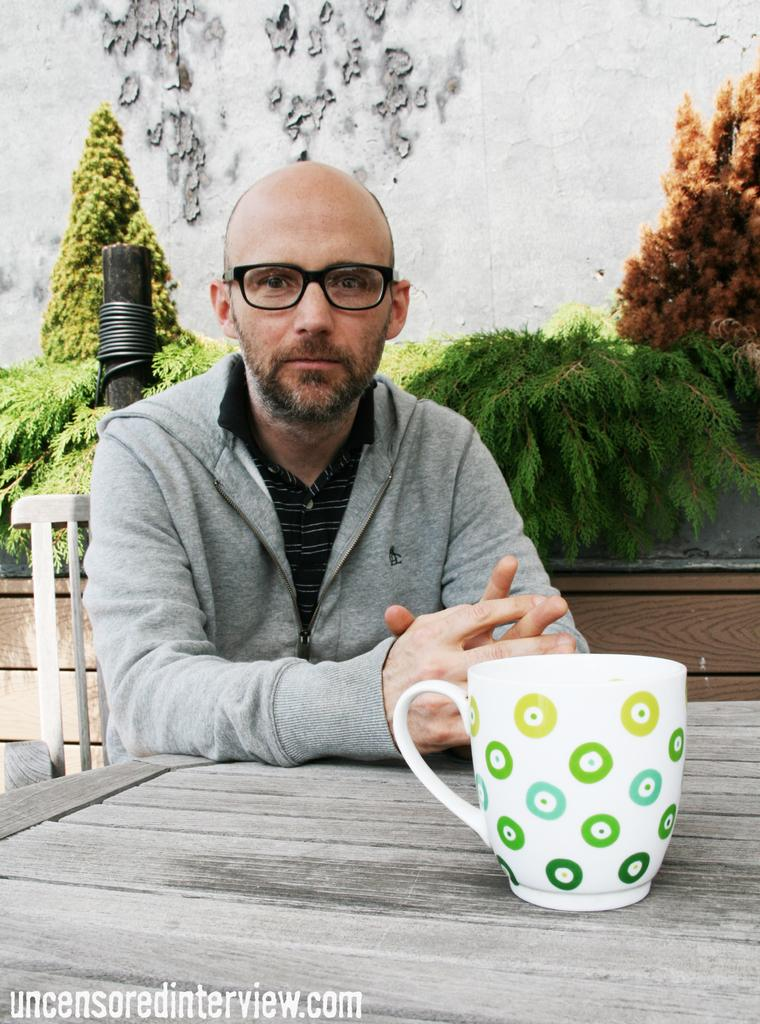What is the man in the image doing? The man is sitting on a chair in the image. What object can be seen near the man? There is a wooden table in the image. What is on the wooden table? A cup is present on the wooden table. What can be seen in the background of the image? There is a wall and a tree in the background of the image. How many rabbits are hopping around the man in the image? There are no rabbits present in the image. What type of fruit is the man holding in the image? The man is not holding any fruit in the image. 